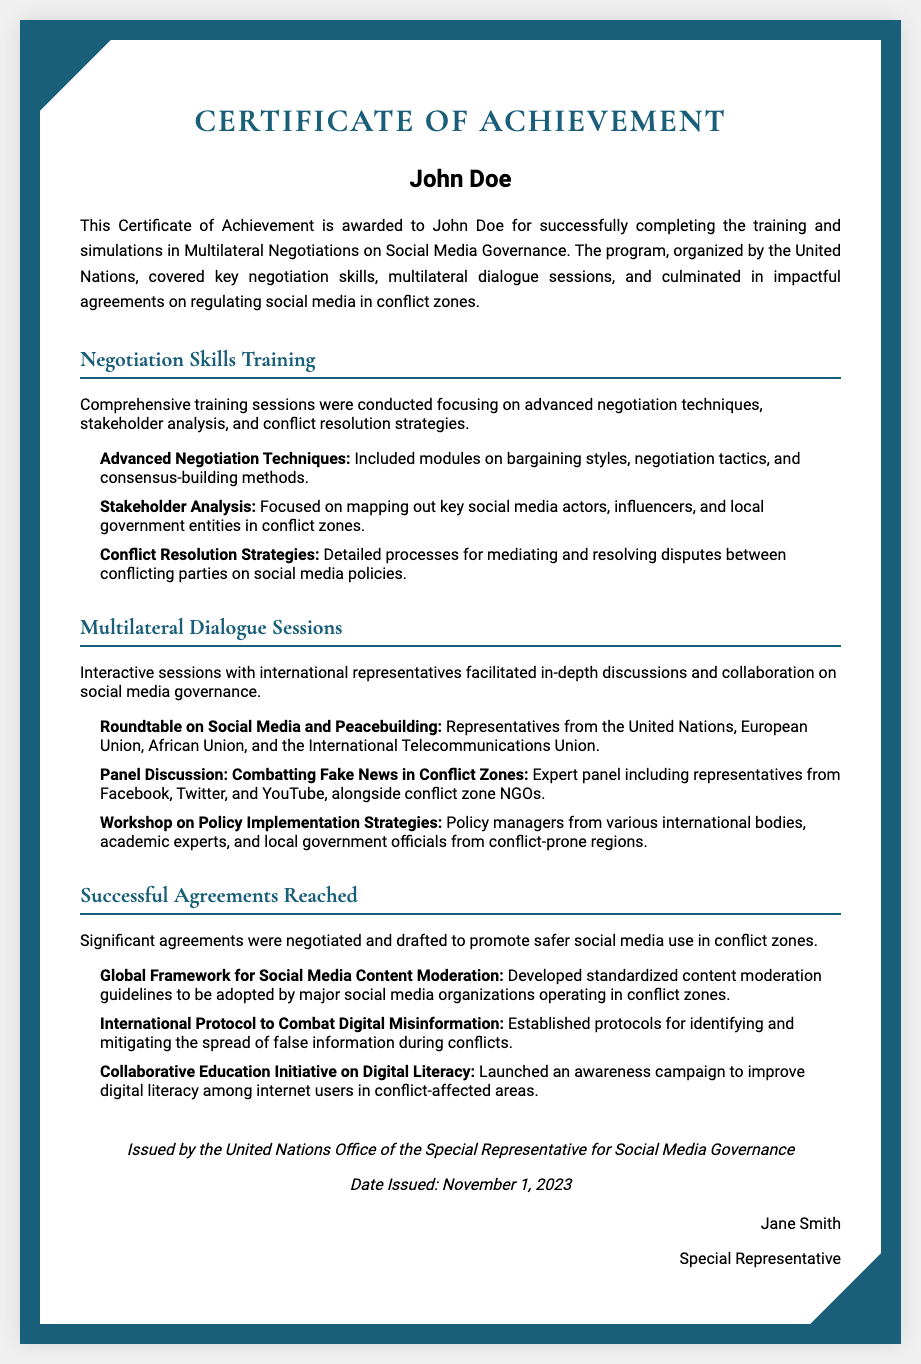What is the title of the certificate? The title of the certificate is prominently displayed at the top of the document.
Answer: Certificate of Achievement Who is the recipient of the certificate? The recipient's name is clearly stated below the title on the certificate.
Answer: John Doe When was the certificate issued? The issue date is mentioned in the footer of the document.
Answer: November 1, 2023 What organization issued the certificate? The issuing organization is specified at the bottom of the certificate.
Answer: United Nations Office of the Special Representative for Social Media Governance What training focused on advanced negotiation techniques? The document lists various sections detailing the content covered in the training sessions.
Answer: Negotiation Skills Training How many successful agreements were reached in the program? The section on successful agreements provides a summary of the agreements made.
Answer: Three Name one focus area of the multilateral dialogue sessions. The document provides specific examples of sessions held as part of the dialogue.
Answer: Combatting Fake News in Conflict Zones Who is the signatory of the certificate? The signature section at the bottom of the document specifies who signed it.
Answer: Jane Smith What is one of the agreements reached regarding digital misinformation? The agreements section lists specific protocols established during negotiations.
Answer: International Protocol to Combat Digital Misinformation What is one module included in the negotiation skills training? The document enumerates specific modules within the training session.
Answer: Advanced Negotiation Techniques 